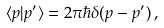<formula> <loc_0><loc_0><loc_500><loc_500>\langle p | p ^ { \prime } \rangle = 2 \pi \hbar { \delta } ( p - p ^ { \prime } ) \, ,</formula> 